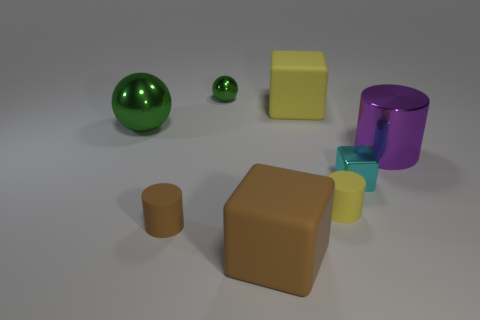Subtract all big rubber blocks. How many blocks are left? 1 Subtract 1 cubes. How many cubes are left? 2 Add 1 yellow cubes. How many objects exist? 9 Subtract all red cubes. Subtract all brown cylinders. How many cubes are left? 3 Subtract all balls. How many objects are left? 6 Add 4 large brown rubber objects. How many large brown rubber objects are left? 5 Add 5 yellow rubber cylinders. How many yellow rubber cylinders exist? 6 Subtract 0 blue blocks. How many objects are left? 8 Subtract all big green rubber cubes. Subtract all tiny green spheres. How many objects are left? 7 